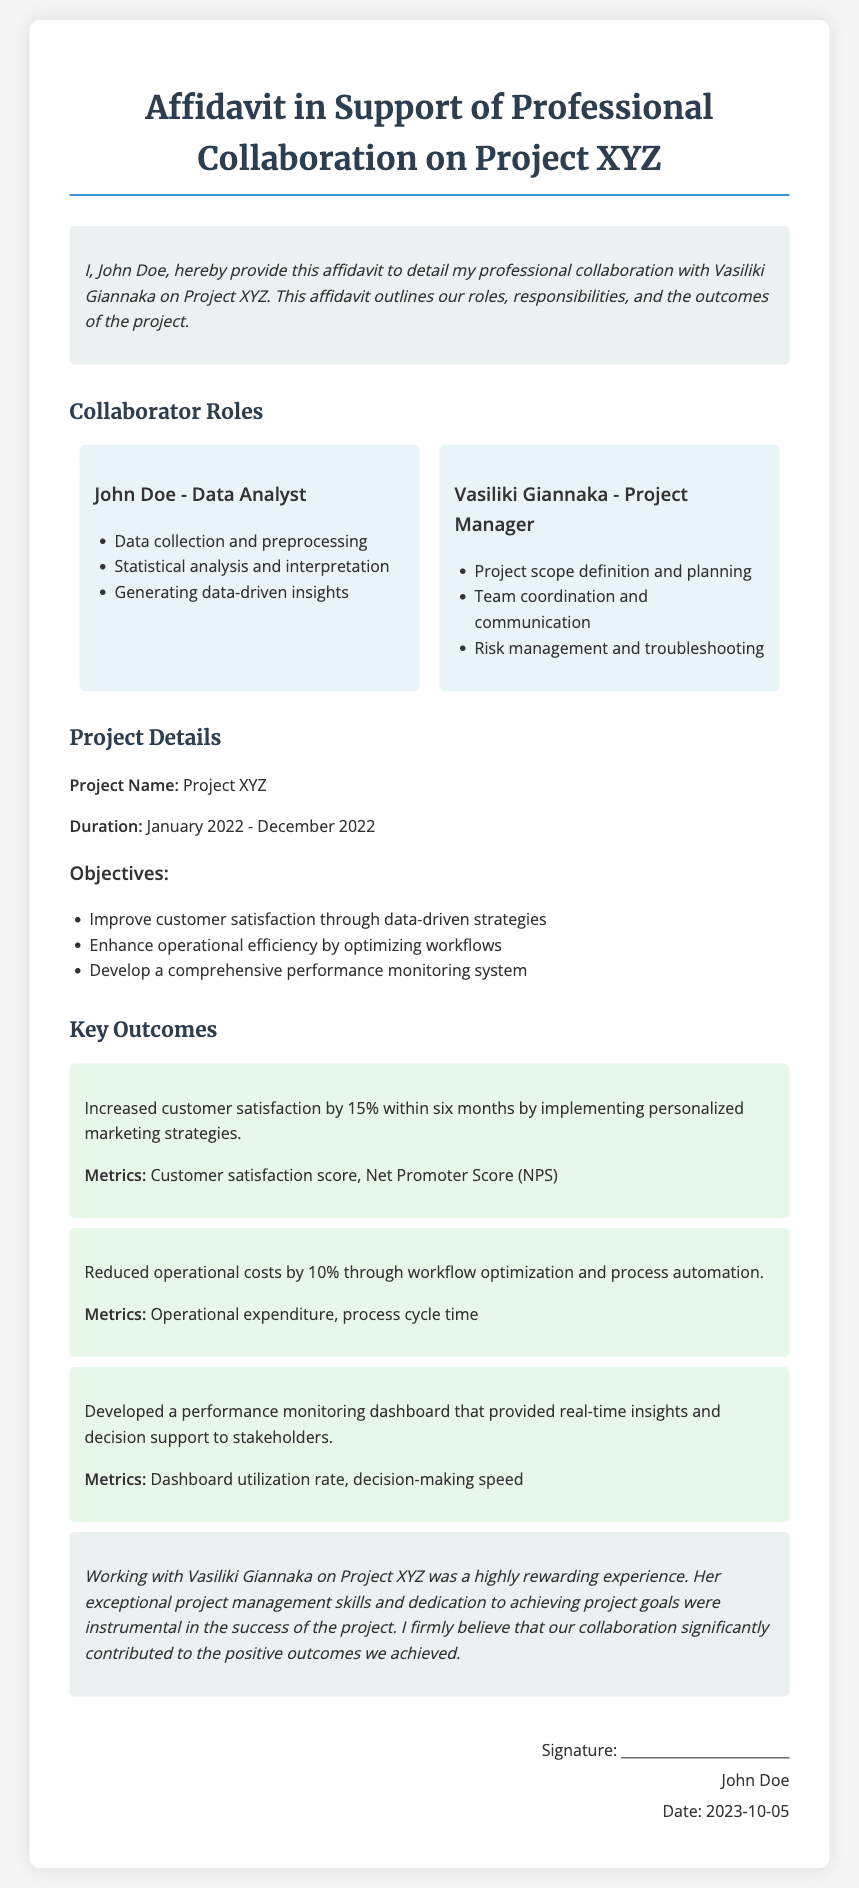What is the name of the project? The name of the project is clearly stated in the document.
Answer: Project XYZ Who is the author of the affidavit? The affidavit states the author's name at the beginning.
Answer: John Doe What was Vasiliki Giannaka's role? The document specifies her position within the project.
Answer: Project Manager What was the duration of Project XYZ? The document explicitly mentions the start and end dates of the project.
Answer: January 2022 - December 2022 By how much did customer satisfaction increase? The outcomes section provides a specific percentage related to customer satisfaction.
Answer: 15% What was one of the objectives of the project? One of the objectives is listed in a bullet point format in the document.
Answer: Improve customer satisfaction through data-driven strategies How much were operational costs reduced by? The outcomes part indicates the percentage reduction achieved.
Answer: 10% What type of dashboard was developed? The document specifies the function and characteristics of the dashboard.
Answer: Performance monitoring dashboard What is the date on the signature? The signature section reveals the date associated with the affidavit.
Answer: 2023-10-05 